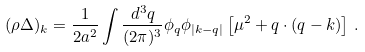Convert formula to latex. <formula><loc_0><loc_0><loc_500><loc_500>( \rho \Delta ) _ { k } = \frac { 1 } { 2 a ^ { 2 } } \int \frac { d ^ { 3 } q } { ( 2 \pi ) ^ { 3 } } \phi _ { q } \phi _ { | k - q | } \left [ \mu ^ { 2 } + q \cdot ( q - k ) \right ] \, .</formula> 